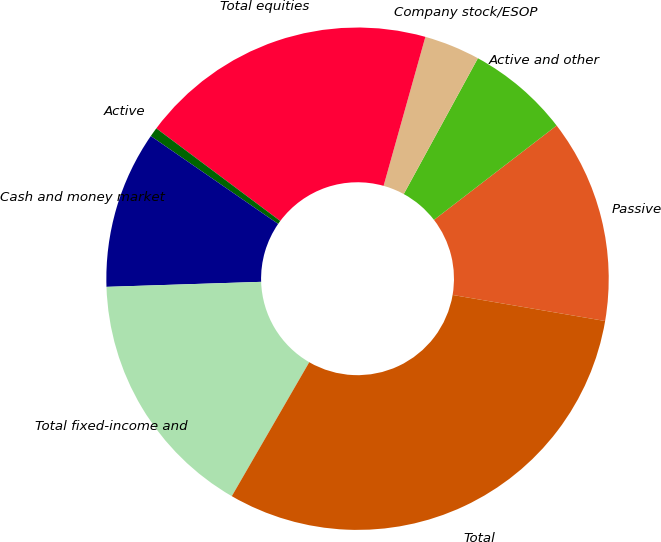<chart> <loc_0><loc_0><loc_500><loc_500><pie_chart><fcel>Passive<fcel>Active and other<fcel>Company stock/ESOP<fcel>Total equities<fcel>Active<fcel>Cash and money market<fcel>Total fixed-income and<fcel>Total<nl><fcel>13.13%<fcel>6.61%<fcel>3.6%<fcel>19.14%<fcel>0.6%<fcel>10.13%<fcel>16.14%<fcel>30.65%<nl></chart> 